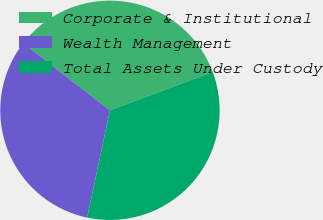<chart> <loc_0><loc_0><loc_500><loc_500><pie_chart><fcel>Corporate & Institutional<fcel>Wealth Management<fcel>Total Assets Under Custody<nl><fcel>33.84%<fcel>32.15%<fcel>34.01%<nl></chart> 